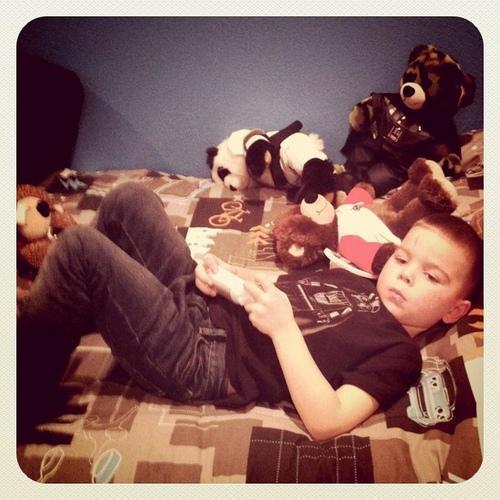How many teddy bears are there?
Give a very brief answer. 4. 